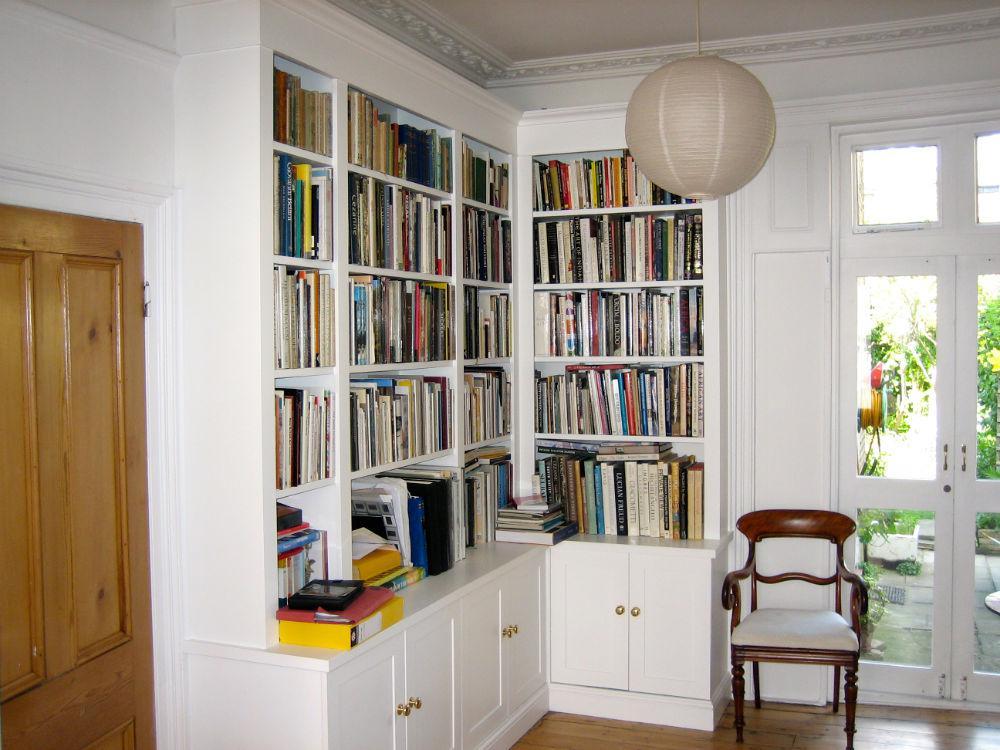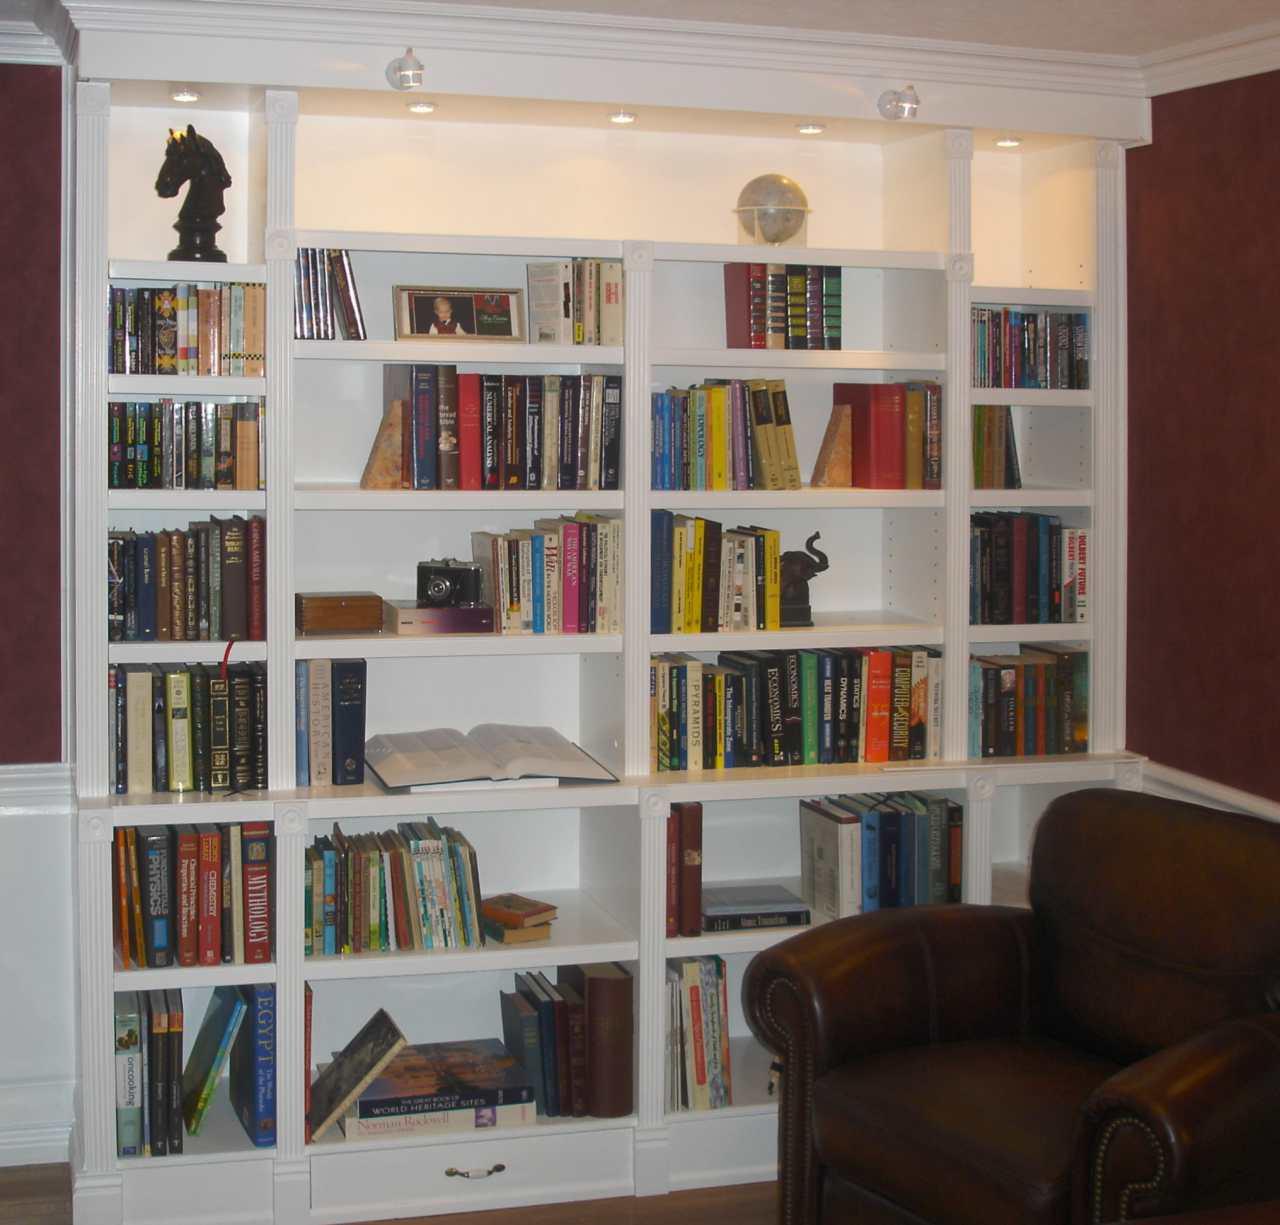The first image is the image on the left, the second image is the image on the right. For the images shown, is this caption "One of the bookcases show is adjacent to some windows." true? Answer yes or no. Yes. The first image is the image on the left, the second image is the image on the right. For the images shown, is this caption "there is a white shelving unit with two whicker cubby boxes on the bottom row and a chalk board on the right" true? Answer yes or no. No. 